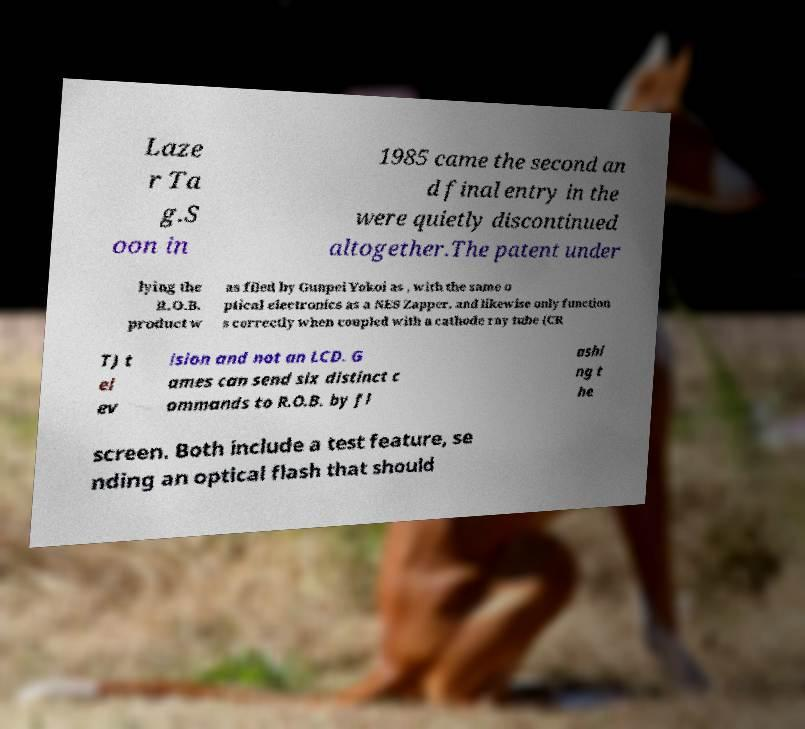Could you assist in decoding the text presented in this image and type it out clearly? Laze r Ta g.S oon in 1985 came the second an d final entry in the were quietly discontinued altogether.The patent under lying the R.O.B. product w as filed by Gunpei Yokoi as , with the same o ptical electronics as a NES Zapper, and likewise only function s correctly when coupled with a cathode ray tube (CR T) t el ev ision and not an LCD. G ames can send six distinct c ommands to R.O.B. by fl ashi ng t he screen. Both include a test feature, se nding an optical flash that should 